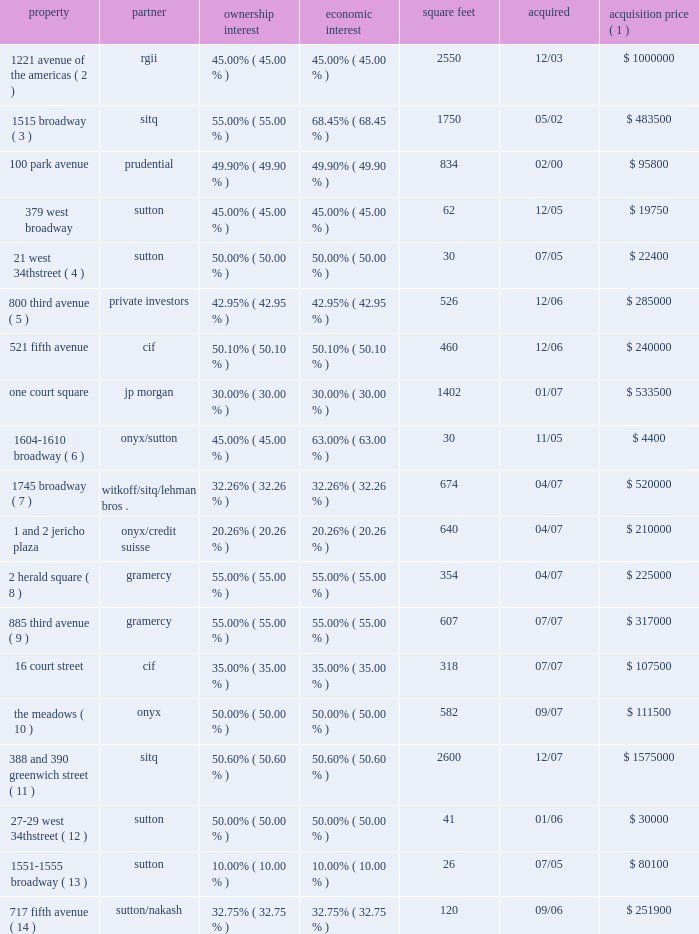Notes to consolidated financial statements minority partner approves the annual budget , receives a detailed monthly reporting package from us , meets with us on a quarterly basis to review the results of the joint venture , reviews and approves the joint venture 2019s tax return before filing , and approves all leases that cover more than a nominal amount of space relative to the total rentable space at each property we do not consolidate the joint venture as we consider these to be substantive participation rights .
Our joint venture agreements also contain certain pro- tective rights such as the requirement of partner approval to sell , finance or refinance the property and the payment of capital expenditures and operating expenditures outside of the approved budget or operating plan .
The table below provides general information on each joint venture as of december 31 , 2009 ( in thousands ) : property partner ownership interest economic interest square feet acquired acquisition price ( 1 ) 1221 avenue of the americas ( 2 ) rgii 45.00% ( 45.00 % ) 45.00% ( 45.00 % ) 2550 12/03 $ 1000000 1515 broadway ( 3 ) sitq 55.00% ( 55.00 % ) 68.45% ( 68.45 % ) 1750 05/02 $ 483500 .
The meadows ( 10 ) onyx 50.00% ( 50.00 % ) 50.00% ( 50.00 % ) 582 09/07 $ 111500 388 and 390 greenwich street ( 11 ) sitq 50.60% ( 50.60 % ) 50.60% ( 50.60 % ) 2600 12/07 $ 1575000 27 201329 west 34th street ( 12 ) sutton 50.00% ( 50.00 % ) 50.00% ( 50.00 % ) 41 01/06 $ 30000 1551 20131555 broadway ( 13 ) sutton 10.00% ( 10.00 % ) 10.00% ( 10.00 % ) 26 07/05 $ 80100 717 fifth avenue ( 14 ) sutton/nakash 32.75% ( 32.75 % ) 32.75% ( 32.75 % ) 120 09/06 $ 251900 ( 1 ) acquisition price represents the actual or implied purchase price for the joint venture .
( 2 ) we acquired our interest from the mcgraw-hill companies , or mhc .
Mhc is a tenant at the property and accounted for approximately 14.7% ( 14.7 % ) of the property 2019s annualized rent at december 31 , 2009 .
We do not manage this joint venture .
( 3 ) under a tax protection agreement established to protect the limited partners of the partnership that transferred 1515 broadway to the joint venture , the joint venture has agreed not to adversely affect the limited partners 2019 tax positions before december 2011 .
One tenant , whose leases primarily ends in 2015 , represents approximately 77.4% ( 77.4 % ) of this joint venture 2019s annualized rent at december 31 , 2009 .
( 4 ) effective november 2006 , we deconsolidated this investment .
As a result of the recapitalization of the property , we were no longer the primary beneficiary .
Both partners had the same amount of equity at risk and neither partner controlled the joint venture .
( 5 ) we invested approximately $ 109.5 million in this asset through the origination of a loan secured by up to 47% ( 47 % ) of the interests in the property 2019s ownership , with an option to convert the loan to an equity interest .
Certain existing members have the right to re-acquire approximately 4% ( 4 % ) of the property 2019s equity .
These interests were re-acquired in december 2008 and reduced our interest to 42.95% ( 42.95 % ) ( 6 ) effective april 2007 , we deconsolidated this investment .
As a result of the recapitalization of the property , we were no longer the primary beneficiary .
Both partners had the same amount of equity at risk and neither partner controlled the joint venture .
( 7 ) we have the ability to syndicate our interest down to 14.79% ( 14.79 % ) .
( 8 ) we , along with gramercy , together as tenants-in-common , acquired a fee interest in 2 herald square .
The fee interest is subject to a long-term operating lease .
( 9 ) we , along with gramercy , together as tenants-in-common , acquired a fee and leasehold interest in 885 third avenue .
The fee and leasehold interests are subject to a long-term operating lease .
( 10 ) we , along with onyx acquired the remaining 50% ( 50 % ) interest on a pro-rata basis in september 2009 .
( 11 ) the property is subject to a 13-year triple-net lease arrangement with a single tenant .
( 12 ) effective may 2008 , we deconsolidated this investment .
As a result of the recapitalization of the property , we were no longer the primary beneficiary .
Both partners had the same amount of equity at risk and neither partner controlled the joint venture .
( 13 ) effective august 2008 , we deconsolidated this investment .
As a result of the sale of 80% ( 80 % ) of our interest , the joint venture was no longer a vie .
( 14 ) effective september 2008 , we deconsolidated this investment .
As a result of the recapitalization of the property , we were no longer the primary beneficiary. .
What was the total value of the 1745 broadway property as of april 2007 based on the acquisition price? 
Computations: ((520000 * 1000) / 32.26%)
Answer: 1611903285.80285. 